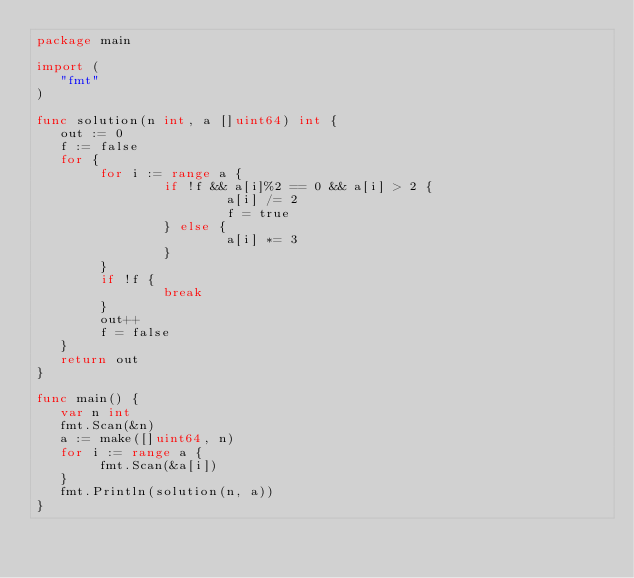Convert code to text. <code><loc_0><loc_0><loc_500><loc_500><_Go_>package main

import (
   "fmt"
)

func solution(n int, a []uint64) int {
   out := 0
   f := false
   for {
        for i := range a {
                if !f && a[i]%2 == 0 && a[i] > 2 {
                        a[i] /= 2
                        f = true
                } else {
                        a[i] *= 3
                }
        }
        if !f {
                break
        }
        out++
        f = false
   }
   return out
}

func main() {
   var n int
   fmt.Scan(&n)
   a := make([]uint64, n)
   for i := range a {
        fmt.Scan(&a[i])
   }
   fmt.Println(solution(n, a))
}</code> 